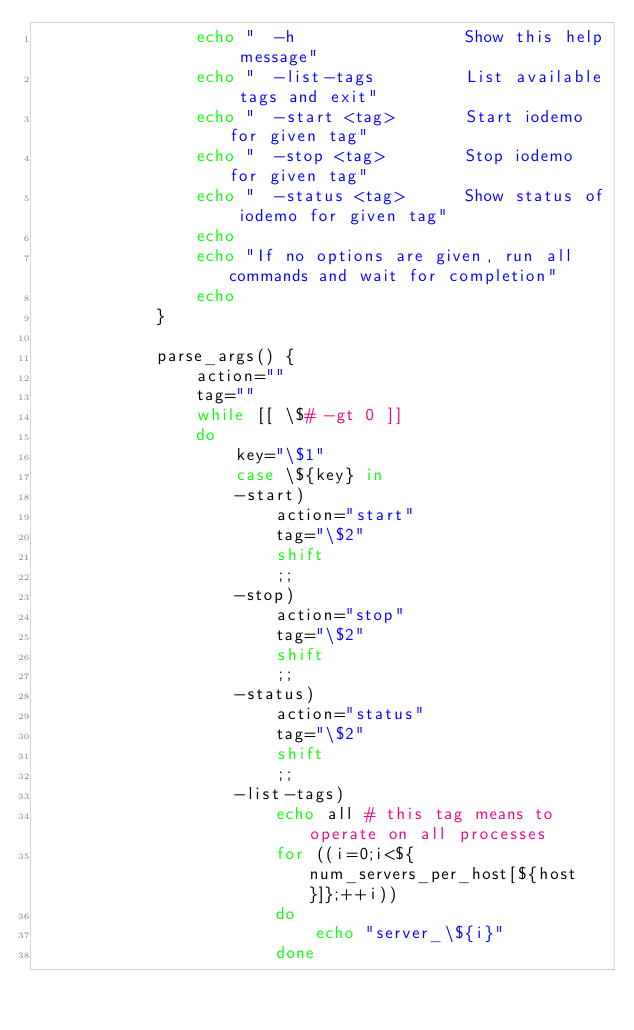Convert code to text. <code><loc_0><loc_0><loc_500><loc_500><_Bash_>			    echo "  -h                 Show this help message"
			    echo "  -list-tags         List available tags and exit"
			    echo "  -start <tag>       Start iodemo for given tag"
			    echo "  -stop <tag>        Stop iodemo for given tag"
			    echo "  -status <tag>      Show status of iodemo for given tag"
			    echo
			    echo "If no options are given, run all commands and wait for completion"
			    echo
			}

			parse_args() {
			    action=""
			    tag=""
			    while [[ \$# -gt 0 ]]
			    do
			        key="\$1"
			        case \${key} in
			        -start)
			            action="start"
			            tag="\$2"
			            shift
			            ;;
			        -stop)
			            action="stop"
			            tag="\$2"
			            shift
			            ;;
			        -status)
			            action="status"
			            tag="\$2"
			            shift
			            ;;
			        -list-tags)
			            echo all # this tag means to operate on all processes
			            for ((i=0;i<${num_servers_per_host[${host}]};++i))
			            do
			                echo "server_\${i}"
			            done</code> 